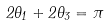Convert formula to latex. <formula><loc_0><loc_0><loc_500><loc_500>2 \theta _ { 1 } + 2 \theta _ { 3 } = \pi</formula> 